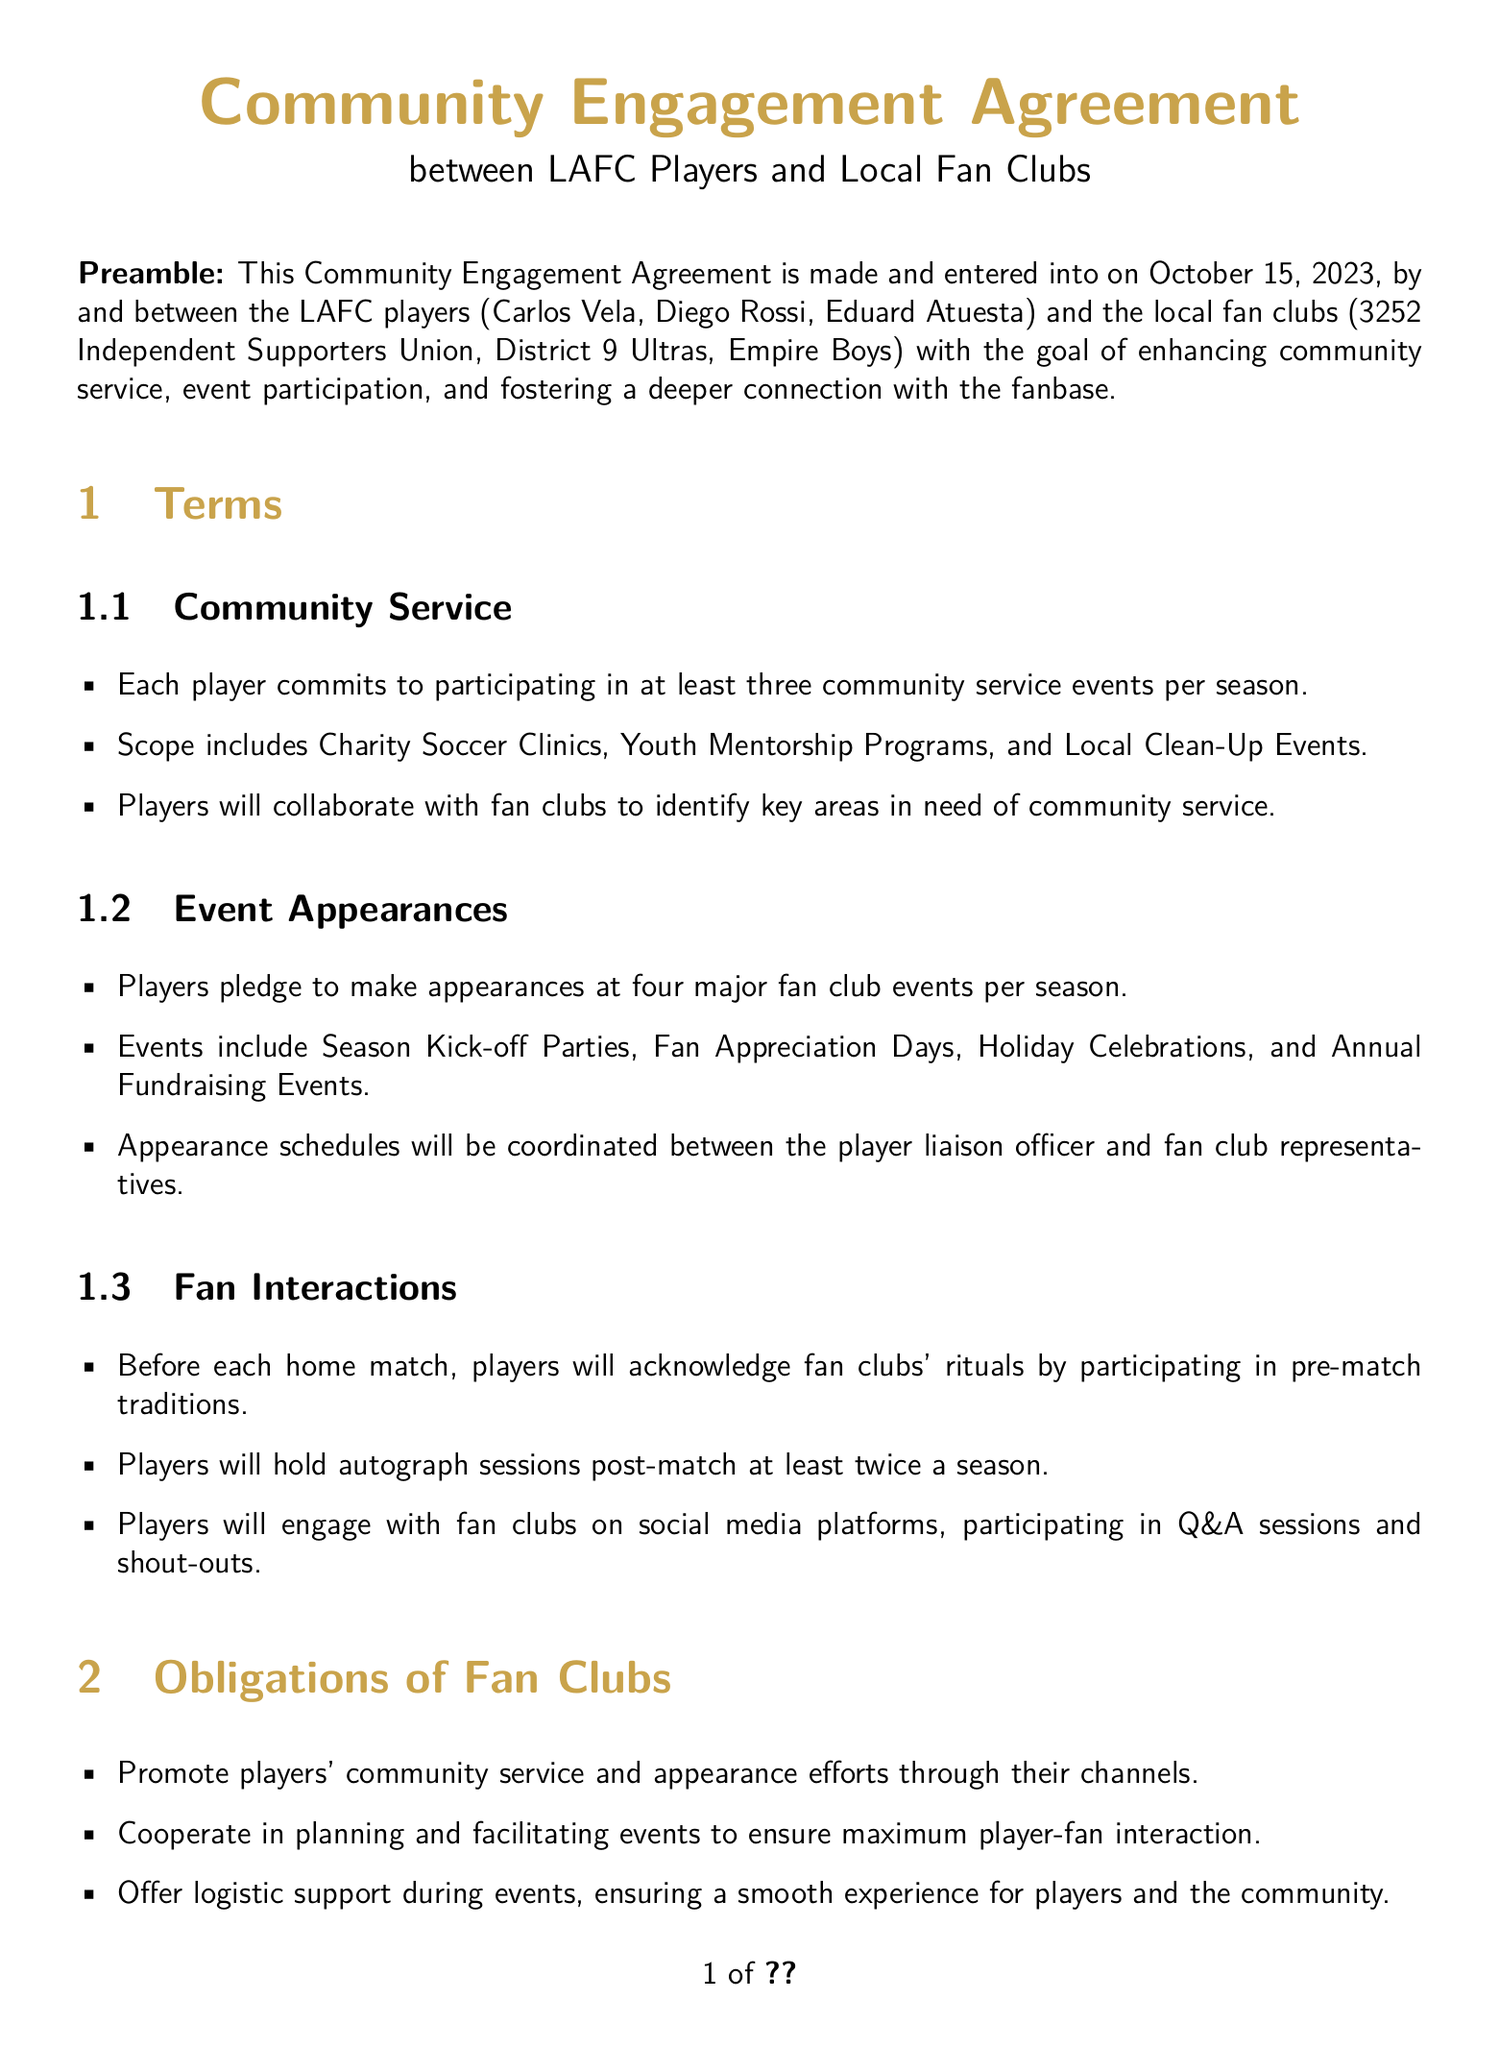What is the date of the agreement? The date of the agreement is specified at the beginning of the document as October 15, 2023.
Answer: October 15, 2023 Who are the players involved in the agreement? The players listed in the document as being part of the agreement are Carlos Vela, Diego Rossi, and Eduard Atuesta.
Answer: Carlos Vela, Diego Rossi, Eduard Atuesta How many community service events must each player attend? The document specifies that each player commits to participating in at least three community service events per season.
Answer: Three What type of events are players required to attend? The events that players are required to attend include Season Kick-off Parties, Fan Appreciation Days, Holiday Celebrations, and Annual Fundraising Events.
Answer: Season Kick-off Parties, Fan Appreciation Days, Holiday Celebrations, Annual Fundraising Events What is the obligation of fan clubs regarding event planning? The fan clubs' obligation concerning event planning is to cooperate in planning and facilitating events to ensure maximum player-fan interaction.
Answer: Cooperate in planning and facilitating events How many major fan club events are players expected to attend? The document states that players pledge to make appearances at four major fan club events per season.
Answer: Four What type of support are fan clubs expected to offer during events? The document mentions that fan clubs are to offer logistic support during events to ensure a smooth experience for players and the community.
Answer: Logistic support How often will players hold autograph sessions? According to the document, players will hold autograph sessions post-match at least twice a season.
Answer: Twice What law governs this agreement? The governing law mentioned in the document is that of the State of California.
Answer: State of California 